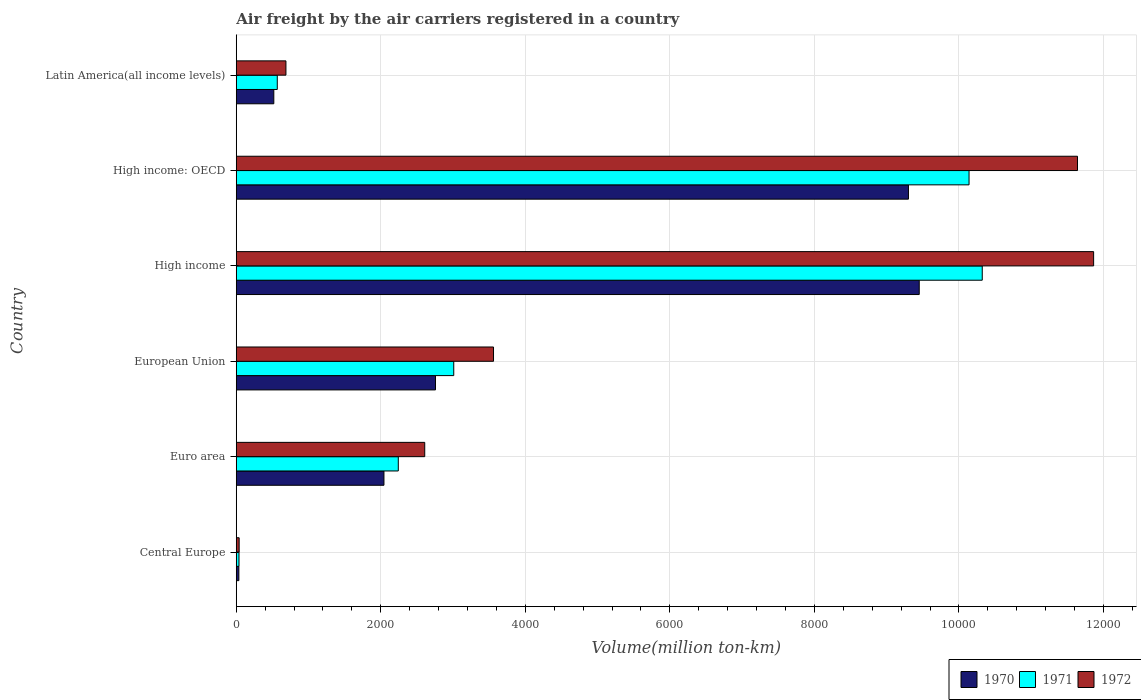How many different coloured bars are there?
Offer a terse response. 3. How many groups of bars are there?
Give a very brief answer. 6. Are the number of bars per tick equal to the number of legend labels?
Provide a succinct answer. Yes. How many bars are there on the 6th tick from the top?
Give a very brief answer. 3. What is the volume of the air carriers in 1971 in European Union?
Offer a very short reply. 3009.4. Across all countries, what is the maximum volume of the air carriers in 1971?
Offer a very short reply. 1.03e+04. Across all countries, what is the minimum volume of the air carriers in 1970?
Offer a terse response. 36. In which country was the volume of the air carriers in 1972 minimum?
Make the answer very short. Central Europe. What is the total volume of the air carriers in 1972 in the graph?
Make the answer very short. 3.04e+04. What is the difference between the volume of the air carriers in 1970 in European Union and that in High income?
Make the answer very short. -6693.2. What is the difference between the volume of the air carriers in 1971 in European Union and the volume of the air carriers in 1970 in Central Europe?
Give a very brief answer. 2973.4. What is the average volume of the air carriers in 1971 per country?
Provide a short and direct response. 4386.35. What is the difference between the volume of the air carriers in 1970 and volume of the air carriers in 1972 in European Union?
Your response must be concise. -802.8. In how many countries, is the volume of the air carriers in 1971 greater than 2400 million ton-km?
Offer a terse response. 3. What is the ratio of the volume of the air carriers in 1972 in High income to that in Latin America(all income levels)?
Your answer should be very brief. 17.26. Is the volume of the air carriers in 1970 in European Union less than that in High income?
Your response must be concise. Yes. Is the difference between the volume of the air carriers in 1970 in Central Europe and High income: OECD greater than the difference between the volume of the air carriers in 1972 in Central Europe and High income: OECD?
Provide a succinct answer. Yes. What is the difference between the highest and the second highest volume of the air carriers in 1970?
Provide a short and direct response. 149.1. What is the difference between the highest and the lowest volume of the air carriers in 1970?
Provide a short and direct response. 9414. In how many countries, is the volume of the air carriers in 1971 greater than the average volume of the air carriers in 1971 taken over all countries?
Make the answer very short. 2. Is the sum of the volume of the air carriers in 1970 in Euro area and Latin America(all income levels) greater than the maximum volume of the air carriers in 1971 across all countries?
Give a very brief answer. No. What does the 2nd bar from the top in High income represents?
Keep it short and to the point. 1971. What is the difference between two consecutive major ticks on the X-axis?
Keep it short and to the point. 2000. Does the graph contain grids?
Provide a succinct answer. Yes. Where does the legend appear in the graph?
Give a very brief answer. Bottom right. How many legend labels are there?
Your answer should be very brief. 3. How are the legend labels stacked?
Offer a very short reply. Horizontal. What is the title of the graph?
Offer a very short reply. Air freight by the air carriers registered in a country. What is the label or title of the X-axis?
Provide a succinct answer. Volume(million ton-km). What is the label or title of the Y-axis?
Your response must be concise. Country. What is the Volume(million ton-km) in 1970 in Central Europe?
Your answer should be very brief. 36. What is the Volume(million ton-km) of 1971 in Central Europe?
Ensure brevity in your answer.  37.9. What is the Volume(million ton-km) in 1972 in Central Europe?
Your answer should be very brief. 40.1. What is the Volume(million ton-km) of 1970 in Euro area?
Ensure brevity in your answer.  2043.6. What is the Volume(million ton-km) of 1971 in Euro area?
Your answer should be very brief. 2242.1. What is the Volume(million ton-km) in 1972 in Euro area?
Your response must be concise. 2607.9. What is the Volume(million ton-km) of 1970 in European Union?
Your answer should be compact. 2756.8. What is the Volume(million ton-km) of 1971 in European Union?
Give a very brief answer. 3009.4. What is the Volume(million ton-km) in 1972 in European Union?
Offer a very short reply. 3559.6. What is the Volume(million ton-km) of 1970 in High income?
Your answer should be compact. 9450. What is the Volume(million ton-km) of 1971 in High income?
Keep it short and to the point. 1.03e+04. What is the Volume(million ton-km) in 1972 in High income?
Ensure brevity in your answer.  1.19e+04. What is the Volume(million ton-km) in 1970 in High income: OECD?
Offer a very short reply. 9300.9. What is the Volume(million ton-km) in 1971 in High income: OECD?
Provide a succinct answer. 1.01e+04. What is the Volume(million ton-km) in 1972 in High income: OECD?
Your response must be concise. 1.16e+04. What is the Volume(million ton-km) of 1970 in Latin America(all income levels)?
Make the answer very short. 519.6. What is the Volume(million ton-km) of 1971 in Latin America(all income levels)?
Offer a very short reply. 567.6. What is the Volume(million ton-km) of 1972 in Latin America(all income levels)?
Make the answer very short. 687.4. Across all countries, what is the maximum Volume(million ton-km) in 1970?
Make the answer very short. 9450. Across all countries, what is the maximum Volume(million ton-km) in 1971?
Offer a terse response. 1.03e+04. Across all countries, what is the maximum Volume(million ton-km) in 1972?
Keep it short and to the point. 1.19e+04. Across all countries, what is the minimum Volume(million ton-km) of 1970?
Give a very brief answer. 36. Across all countries, what is the minimum Volume(million ton-km) in 1971?
Keep it short and to the point. 37.9. Across all countries, what is the minimum Volume(million ton-km) in 1972?
Offer a terse response. 40.1. What is the total Volume(million ton-km) in 1970 in the graph?
Your answer should be compact. 2.41e+04. What is the total Volume(million ton-km) in 1971 in the graph?
Provide a succinct answer. 2.63e+04. What is the total Volume(million ton-km) of 1972 in the graph?
Your response must be concise. 3.04e+04. What is the difference between the Volume(million ton-km) of 1970 in Central Europe and that in Euro area?
Your answer should be very brief. -2007.6. What is the difference between the Volume(million ton-km) of 1971 in Central Europe and that in Euro area?
Your answer should be very brief. -2204.2. What is the difference between the Volume(million ton-km) of 1972 in Central Europe and that in Euro area?
Ensure brevity in your answer.  -2567.8. What is the difference between the Volume(million ton-km) in 1970 in Central Europe and that in European Union?
Offer a very short reply. -2720.8. What is the difference between the Volume(million ton-km) in 1971 in Central Europe and that in European Union?
Your answer should be very brief. -2971.5. What is the difference between the Volume(million ton-km) in 1972 in Central Europe and that in European Union?
Offer a terse response. -3519.5. What is the difference between the Volume(million ton-km) in 1970 in Central Europe and that in High income?
Your response must be concise. -9414. What is the difference between the Volume(million ton-km) in 1971 in Central Europe and that in High income?
Your answer should be very brief. -1.03e+04. What is the difference between the Volume(million ton-km) in 1972 in Central Europe and that in High income?
Offer a very short reply. -1.18e+04. What is the difference between the Volume(million ton-km) in 1970 in Central Europe and that in High income: OECD?
Your response must be concise. -9264.9. What is the difference between the Volume(million ton-km) in 1971 in Central Europe and that in High income: OECD?
Provide a short and direct response. -1.01e+04. What is the difference between the Volume(million ton-km) of 1972 in Central Europe and that in High income: OECD?
Your answer should be very brief. -1.16e+04. What is the difference between the Volume(million ton-km) in 1970 in Central Europe and that in Latin America(all income levels)?
Offer a very short reply. -483.6. What is the difference between the Volume(million ton-km) of 1971 in Central Europe and that in Latin America(all income levels)?
Your answer should be very brief. -529.7. What is the difference between the Volume(million ton-km) in 1972 in Central Europe and that in Latin America(all income levels)?
Your answer should be compact. -647.3. What is the difference between the Volume(million ton-km) in 1970 in Euro area and that in European Union?
Keep it short and to the point. -713.2. What is the difference between the Volume(million ton-km) of 1971 in Euro area and that in European Union?
Your answer should be compact. -767.3. What is the difference between the Volume(million ton-km) in 1972 in Euro area and that in European Union?
Provide a succinct answer. -951.7. What is the difference between the Volume(million ton-km) of 1970 in Euro area and that in High income?
Offer a terse response. -7406.4. What is the difference between the Volume(million ton-km) in 1971 in Euro area and that in High income?
Your response must be concise. -8079.8. What is the difference between the Volume(million ton-km) in 1972 in Euro area and that in High income?
Your answer should be very brief. -9255. What is the difference between the Volume(million ton-km) of 1970 in Euro area and that in High income: OECD?
Offer a terse response. -7257.3. What is the difference between the Volume(million ton-km) in 1971 in Euro area and that in High income: OECD?
Offer a very short reply. -7897.1. What is the difference between the Volume(million ton-km) of 1972 in Euro area and that in High income: OECD?
Your response must be concise. -9031.8. What is the difference between the Volume(million ton-km) of 1970 in Euro area and that in Latin America(all income levels)?
Ensure brevity in your answer.  1524. What is the difference between the Volume(million ton-km) in 1971 in Euro area and that in Latin America(all income levels)?
Keep it short and to the point. 1674.5. What is the difference between the Volume(million ton-km) in 1972 in Euro area and that in Latin America(all income levels)?
Offer a terse response. 1920.5. What is the difference between the Volume(million ton-km) in 1970 in European Union and that in High income?
Ensure brevity in your answer.  -6693.2. What is the difference between the Volume(million ton-km) of 1971 in European Union and that in High income?
Ensure brevity in your answer.  -7312.5. What is the difference between the Volume(million ton-km) of 1972 in European Union and that in High income?
Provide a short and direct response. -8303.3. What is the difference between the Volume(million ton-km) of 1970 in European Union and that in High income: OECD?
Give a very brief answer. -6544.1. What is the difference between the Volume(million ton-km) in 1971 in European Union and that in High income: OECD?
Give a very brief answer. -7129.8. What is the difference between the Volume(million ton-km) of 1972 in European Union and that in High income: OECD?
Ensure brevity in your answer.  -8080.1. What is the difference between the Volume(million ton-km) in 1970 in European Union and that in Latin America(all income levels)?
Offer a very short reply. 2237.2. What is the difference between the Volume(million ton-km) in 1971 in European Union and that in Latin America(all income levels)?
Provide a succinct answer. 2441.8. What is the difference between the Volume(million ton-km) in 1972 in European Union and that in Latin America(all income levels)?
Your response must be concise. 2872.2. What is the difference between the Volume(million ton-km) in 1970 in High income and that in High income: OECD?
Your answer should be very brief. 149.1. What is the difference between the Volume(million ton-km) in 1971 in High income and that in High income: OECD?
Offer a very short reply. 182.7. What is the difference between the Volume(million ton-km) of 1972 in High income and that in High income: OECD?
Your answer should be compact. 223.2. What is the difference between the Volume(million ton-km) in 1970 in High income and that in Latin America(all income levels)?
Provide a succinct answer. 8930.4. What is the difference between the Volume(million ton-km) in 1971 in High income and that in Latin America(all income levels)?
Provide a short and direct response. 9754.3. What is the difference between the Volume(million ton-km) in 1972 in High income and that in Latin America(all income levels)?
Offer a terse response. 1.12e+04. What is the difference between the Volume(million ton-km) in 1970 in High income: OECD and that in Latin America(all income levels)?
Your answer should be very brief. 8781.3. What is the difference between the Volume(million ton-km) of 1971 in High income: OECD and that in Latin America(all income levels)?
Your answer should be compact. 9571.6. What is the difference between the Volume(million ton-km) in 1972 in High income: OECD and that in Latin America(all income levels)?
Make the answer very short. 1.10e+04. What is the difference between the Volume(million ton-km) of 1970 in Central Europe and the Volume(million ton-km) of 1971 in Euro area?
Your answer should be very brief. -2206.1. What is the difference between the Volume(million ton-km) of 1970 in Central Europe and the Volume(million ton-km) of 1972 in Euro area?
Provide a short and direct response. -2571.9. What is the difference between the Volume(million ton-km) in 1971 in Central Europe and the Volume(million ton-km) in 1972 in Euro area?
Ensure brevity in your answer.  -2570. What is the difference between the Volume(million ton-km) of 1970 in Central Europe and the Volume(million ton-km) of 1971 in European Union?
Ensure brevity in your answer.  -2973.4. What is the difference between the Volume(million ton-km) in 1970 in Central Europe and the Volume(million ton-km) in 1972 in European Union?
Offer a terse response. -3523.6. What is the difference between the Volume(million ton-km) of 1971 in Central Europe and the Volume(million ton-km) of 1972 in European Union?
Keep it short and to the point. -3521.7. What is the difference between the Volume(million ton-km) in 1970 in Central Europe and the Volume(million ton-km) in 1971 in High income?
Your answer should be very brief. -1.03e+04. What is the difference between the Volume(million ton-km) of 1970 in Central Europe and the Volume(million ton-km) of 1972 in High income?
Provide a succinct answer. -1.18e+04. What is the difference between the Volume(million ton-km) in 1971 in Central Europe and the Volume(million ton-km) in 1972 in High income?
Ensure brevity in your answer.  -1.18e+04. What is the difference between the Volume(million ton-km) in 1970 in Central Europe and the Volume(million ton-km) in 1971 in High income: OECD?
Keep it short and to the point. -1.01e+04. What is the difference between the Volume(million ton-km) in 1970 in Central Europe and the Volume(million ton-km) in 1972 in High income: OECD?
Provide a succinct answer. -1.16e+04. What is the difference between the Volume(million ton-km) of 1971 in Central Europe and the Volume(million ton-km) of 1972 in High income: OECD?
Keep it short and to the point. -1.16e+04. What is the difference between the Volume(million ton-km) of 1970 in Central Europe and the Volume(million ton-km) of 1971 in Latin America(all income levels)?
Give a very brief answer. -531.6. What is the difference between the Volume(million ton-km) in 1970 in Central Europe and the Volume(million ton-km) in 1972 in Latin America(all income levels)?
Your answer should be very brief. -651.4. What is the difference between the Volume(million ton-km) in 1971 in Central Europe and the Volume(million ton-km) in 1972 in Latin America(all income levels)?
Provide a succinct answer. -649.5. What is the difference between the Volume(million ton-km) of 1970 in Euro area and the Volume(million ton-km) of 1971 in European Union?
Keep it short and to the point. -965.8. What is the difference between the Volume(million ton-km) in 1970 in Euro area and the Volume(million ton-km) in 1972 in European Union?
Keep it short and to the point. -1516. What is the difference between the Volume(million ton-km) in 1971 in Euro area and the Volume(million ton-km) in 1972 in European Union?
Offer a very short reply. -1317.5. What is the difference between the Volume(million ton-km) of 1970 in Euro area and the Volume(million ton-km) of 1971 in High income?
Your answer should be very brief. -8278.3. What is the difference between the Volume(million ton-km) in 1970 in Euro area and the Volume(million ton-km) in 1972 in High income?
Your answer should be compact. -9819.3. What is the difference between the Volume(million ton-km) in 1971 in Euro area and the Volume(million ton-km) in 1972 in High income?
Provide a short and direct response. -9620.8. What is the difference between the Volume(million ton-km) in 1970 in Euro area and the Volume(million ton-km) in 1971 in High income: OECD?
Give a very brief answer. -8095.6. What is the difference between the Volume(million ton-km) in 1970 in Euro area and the Volume(million ton-km) in 1972 in High income: OECD?
Your answer should be compact. -9596.1. What is the difference between the Volume(million ton-km) in 1971 in Euro area and the Volume(million ton-km) in 1972 in High income: OECD?
Give a very brief answer. -9397.6. What is the difference between the Volume(million ton-km) in 1970 in Euro area and the Volume(million ton-km) in 1971 in Latin America(all income levels)?
Your answer should be compact. 1476. What is the difference between the Volume(million ton-km) in 1970 in Euro area and the Volume(million ton-km) in 1972 in Latin America(all income levels)?
Give a very brief answer. 1356.2. What is the difference between the Volume(million ton-km) in 1971 in Euro area and the Volume(million ton-km) in 1972 in Latin America(all income levels)?
Offer a terse response. 1554.7. What is the difference between the Volume(million ton-km) of 1970 in European Union and the Volume(million ton-km) of 1971 in High income?
Provide a succinct answer. -7565.1. What is the difference between the Volume(million ton-km) in 1970 in European Union and the Volume(million ton-km) in 1972 in High income?
Ensure brevity in your answer.  -9106.1. What is the difference between the Volume(million ton-km) of 1971 in European Union and the Volume(million ton-km) of 1972 in High income?
Keep it short and to the point. -8853.5. What is the difference between the Volume(million ton-km) of 1970 in European Union and the Volume(million ton-km) of 1971 in High income: OECD?
Give a very brief answer. -7382.4. What is the difference between the Volume(million ton-km) of 1970 in European Union and the Volume(million ton-km) of 1972 in High income: OECD?
Offer a terse response. -8882.9. What is the difference between the Volume(million ton-km) in 1971 in European Union and the Volume(million ton-km) in 1972 in High income: OECD?
Ensure brevity in your answer.  -8630.3. What is the difference between the Volume(million ton-km) of 1970 in European Union and the Volume(million ton-km) of 1971 in Latin America(all income levels)?
Make the answer very short. 2189.2. What is the difference between the Volume(million ton-km) in 1970 in European Union and the Volume(million ton-km) in 1972 in Latin America(all income levels)?
Ensure brevity in your answer.  2069.4. What is the difference between the Volume(million ton-km) of 1971 in European Union and the Volume(million ton-km) of 1972 in Latin America(all income levels)?
Keep it short and to the point. 2322. What is the difference between the Volume(million ton-km) in 1970 in High income and the Volume(million ton-km) in 1971 in High income: OECD?
Give a very brief answer. -689.2. What is the difference between the Volume(million ton-km) of 1970 in High income and the Volume(million ton-km) of 1972 in High income: OECD?
Ensure brevity in your answer.  -2189.7. What is the difference between the Volume(million ton-km) in 1971 in High income and the Volume(million ton-km) in 1972 in High income: OECD?
Provide a succinct answer. -1317.8. What is the difference between the Volume(million ton-km) in 1970 in High income and the Volume(million ton-km) in 1971 in Latin America(all income levels)?
Your answer should be compact. 8882.4. What is the difference between the Volume(million ton-km) of 1970 in High income and the Volume(million ton-km) of 1972 in Latin America(all income levels)?
Provide a succinct answer. 8762.6. What is the difference between the Volume(million ton-km) of 1971 in High income and the Volume(million ton-km) of 1972 in Latin America(all income levels)?
Provide a short and direct response. 9634.5. What is the difference between the Volume(million ton-km) of 1970 in High income: OECD and the Volume(million ton-km) of 1971 in Latin America(all income levels)?
Keep it short and to the point. 8733.3. What is the difference between the Volume(million ton-km) in 1970 in High income: OECD and the Volume(million ton-km) in 1972 in Latin America(all income levels)?
Provide a short and direct response. 8613.5. What is the difference between the Volume(million ton-km) in 1971 in High income: OECD and the Volume(million ton-km) in 1972 in Latin America(all income levels)?
Provide a short and direct response. 9451.8. What is the average Volume(million ton-km) of 1970 per country?
Provide a short and direct response. 4017.82. What is the average Volume(million ton-km) of 1971 per country?
Your answer should be compact. 4386.35. What is the average Volume(million ton-km) of 1972 per country?
Give a very brief answer. 5066.27. What is the difference between the Volume(million ton-km) in 1970 and Volume(million ton-km) in 1971 in Central Europe?
Your answer should be compact. -1.9. What is the difference between the Volume(million ton-km) of 1970 and Volume(million ton-km) of 1971 in Euro area?
Provide a short and direct response. -198.5. What is the difference between the Volume(million ton-km) in 1970 and Volume(million ton-km) in 1972 in Euro area?
Ensure brevity in your answer.  -564.3. What is the difference between the Volume(million ton-km) of 1971 and Volume(million ton-km) of 1972 in Euro area?
Provide a succinct answer. -365.8. What is the difference between the Volume(million ton-km) in 1970 and Volume(million ton-km) in 1971 in European Union?
Make the answer very short. -252.6. What is the difference between the Volume(million ton-km) in 1970 and Volume(million ton-km) in 1972 in European Union?
Make the answer very short. -802.8. What is the difference between the Volume(million ton-km) in 1971 and Volume(million ton-km) in 1972 in European Union?
Make the answer very short. -550.2. What is the difference between the Volume(million ton-km) in 1970 and Volume(million ton-km) in 1971 in High income?
Offer a very short reply. -871.9. What is the difference between the Volume(million ton-km) of 1970 and Volume(million ton-km) of 1972 in High income?
Provide a short and direct response. -2412.9. What is the difference between the Volume(million ton-km) of 1971 and Volume(million ton-km) of 1972 in High income?
Keep it short and to the point. -1541. What is the difference between the Volume(million ton-km) of 1970 and Volume(million ton-km) of 1971 in High income: OECD?
Offer a terse response. -838.3. What is the difference between the Volume(million ton-km) in 1970 and Volume(million ton-km) in 1972 in High income: OECD?
Your answer should be very brief. -2338.8. What is the difference between the Volume(million ton-km) of 1971 and Volume(million ton-km) of 1972 in High income: OECD?
Offer a terse response. -1500.5. What is the difference between the Volume(million ton-km) in 1970 and Volume(million ton-km) in 1971 in Latin America(all income levels)?
Keep it short and to the point. -48. What is the difference between the Volume(million ton-km) of 1970 and Volume(million ton-km) of 1972 in Latin America(all income levels)?
Give a very brief answer. -167.8. What is the difference between the Volume(million ton-km) in 1971 and Volume(million ton-km) in 1972 in Latin America(all income levels)?
Your answer should be compact. -119.8. What is the ratio of the Volume(million ton-km) of 1970 in Central Europe to that in Euro area?
Your answer should be very brief. 0.02. What is the ratio of the Volume(million ton-km) of 1971 in Central Europe to that in Euro area?
Your answer should be compact. 0.02. What is the ratio of the Volume(million ton-km) in 1972 in Central Europe to that in Euro area?
Ensure brevity in your answer.  0.02. What is the ratio of the Volume(million ton-km) of 1970 in Central Europe to that in European Union?
Your answer should be compact. 0.01. What is the ratio of the Volume(million ton-km) of 1971 in Central Europe to that in European Union?
Provide a short and direct response. 0.01. What is the ratio of the Volume(million ton-km) of 1972 in Central Europe to that in European Union?
Give a very brief answer. 0.01. What is the ratio of the Volume(million ton-km) of 1970 in Central Europe to that in High income?
Offer a terse response. 0. What is the ratio of the Volume(million ton-km) of 1971 in Central Europe to that in High income?
Give a very brief answer. 0. What is the ratio of the Volume(million ton-km) in 1972 in Central Europe to that in High income?
Offer a very short reply. 0. What is the ratio of the Volume(million ton-km) in 1970 in Central Europe to that in High income: OECD?
Provide a succinct answer. 0. What is the ratio of the Volume(million ton-km) in 1971 in Central Europe to that in High income: OECD?
Your response must be concise. 0. What is the ratio of the Volume(million ton-km) of 1972 in Central Europe to that in High income: OECD?
Offer a very short reply. 0. What is the ratio of the Volume(million ton-km) in 1970 in Central Europe to that in Latin America(all income levels)?
Provide a succinct answer. 0.07. What is the ratio of the Volume(million ton-km) in 1971 in Central Europe to that in Latin America(all income levels)?
Offer a very short reply. 0.07. What is the ratio of the Volume(million ton-km) of 1972 in Central Europe to that in Latin America(all income levels)?
Offer a terse response. 0.06. What is the ratio of the Volume(million ton-km) of 1970 in Euro area to that in European Union?
Your answer should be compact. 0.74. What is the ratio of the Volume(million ton-km) of 1971 in Euro area to that in European Union?
Your answer should be very brief. 0.74. What is the ratio of the Volume(million ton-km) of 1972 in Euro area to that in European Union?
Your answer should be compact. 0.73. What is the ratio of the Volume(million ton-km) of 1970 in Euro area to that in High income?
Your response must be concise. 0.22. What is the ratio of the Volume(million ton-km) of 1971 in Euro area to that in High income?
Make the answer very short. 0.22. What is the ratio of the Volume(million ton-km) of 1972 in Euro area to that in High income?
Keep it short and to the point. 0.22. What is the ratio of the Volume(million ton-km) in 1970 in Euro area to that in High income: OECD?
Make the answer very short. 0.22. What is the ratio of the Volume(million ton-km) of 1971 in Euro area to that in High income: OECD?
Your answer should be compact. 0.22. What is the ratio of the Volume(million ton-km) of 1972 in Euro area to that in High income: OECD?
Provide a short and direct response. 0.22. What is the ratio of the Volume(million ton-km) of 1970 in Euro area to that in Latin America(all income levels)?
Offer a very short reply. 3.93. What is the ratio of the Volume(million ton-km) of 1971 in Euro area to that in Latin America(all income levels)?
Your answer should be very brief. 3.95. What is the ratio of the Volume(million ton-km) in 1972 in Euro area to that in Latin America(all income levels)?
Make the answer very short. 3.79. What is the ratio of the Volume(million ton-km) in 1970 in European Union to that in High income?
Your response must be concise. 0.29. What is the ratio of the Volume(million ton-km) of 1971 in European Union to that in High income?
Make the answer very short. 0.29. What is the ratio of the Volume(million ton-km) of 1972 in European Union to that in High income?
Provide a succinct answer. 0.3. What is the ratio of the Volume(million ton-km) in 1970 in European Union to that in High income: OECD?
Keep it short and to the point. 0.3. What is the ratio of the Volume(million ton-km) in 1971 in European Union to that in High income: OECD?
Keep it short and to the point. 0.3. What is the ratio of the Volume(million ton-km) in 1972 in European Union to that in High income: OECD?
Ensure brevity in your answer.  0.31. What is the ratio of the Volume(million ton-km) in 1970 in European Union to that in Latin America(all income levels)?
Keep it short and to the point. 5.31. What is the ratio of the Volume(million ton-km) of 1971 in European Union to that in Latin America(all income levels)?
Offer a very short reply. 5.3. What is the ratio of the Volume(million ton-km) in 1972 in European Union to that in Latin America(all income levels)?
Ensure brevity in your answer.  5.18. What is the ratio of the Volume(million ton-km) of 1970 in High income to that in High income: OECD?
Provide a short and direct response. 1.02. What is the ratio of the Volume(million ton-km) in 1971 in High income to that in High income: OECD?
Your answer should be very brief. 1.02. What is the ratio of the Volume(million ton-km) of 1972 in High income to that in High income: OECD?
Give a very brief answer. 1.02. What is the ratio of the Volume(million ton-km) of 1970 in High income to that in Latin America(all income levels)?
Provide a short and direct response. 18.19. What is the ratio of the Volume(million ton-km) in 1971 in High income to that in Latin America(all income levels)?
Offer a terse response. 18.19. What is the ratio of the Volume(million ton-km) in 1972 in High income to that in Latin America(all income levels)?
Provide a succinct answer. 17.26. What is the ratio of the Volume(million ton-km) in 1970 in High income: OECD to that in Latin America(all income levels)?
Make the answer very short. 17.9. What is the ratio of the Volume(million ton-km) in 1971 in High income: OECD to that in Latin America(all income levels)?
Make the answer very short. 17.86. What is the ratio of the Volume(million ton-km) of 1972 in High income: OECD to that in Latin America(all income levels)?
Your answer should be very brief. 16.93. What is the difference between the highest and the second highest Volume(million ton-km) of 1970?
Give a very brief answer. 149.1. What is the difference between the highest and the second highest Volume(million ton-km) in 1971?
Offer a very short reply. 182.7. What is the difference between the highest and the second highest Volume(million ton-km) in 1972?
Offer a terse response. 223.2. What is the difference between the highest and the lowest Volume(million ton-km) in 1970?
Offer a terse response. 9414. What is the difference between the highest and the lowest Volume(million ton-km) of 1971?
Provide a succinct answer. 1.03e+04. What is the difference between the highest and the lowest Volume(million ton-km) of 1972?
Keep it short and to the point. 1.18e+04. 